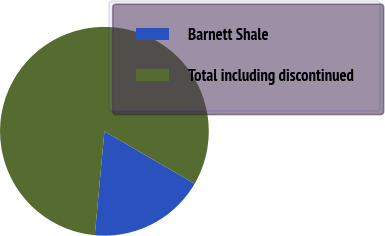Convert chart to OTSL. <chart><loc_0><loc_0><loc_500><loc_500><pie_chart><fcel>Barnett Shale<fcel>Total including discontinued<nl><fcel>18.09%<fcel>81.91%<nl></chart> 